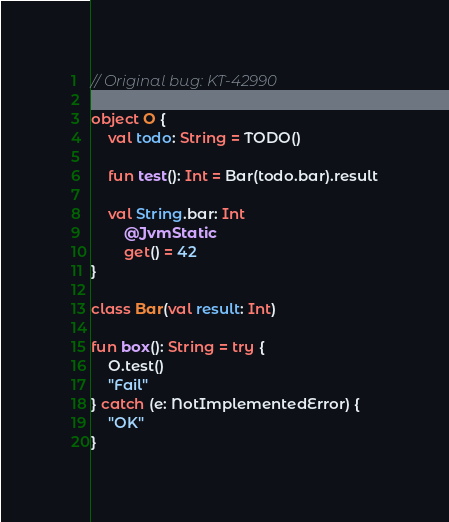<code> <loc_0><loc_0><loc_500><loc_500><_Kotlin_>// Original bug: KT-42990

object O {
    val todo: String = TODO()

    fun test(): Int = Bar(todo.bar).result

    val String.bar: Int
        @JvmStatic
        get() = 42
}

class Bar(val result: Int)

fun box(): String = try {
    O.test()
    "Fail"
} catch (e: NotImplementedError) {
    "OK"
}
</code> 